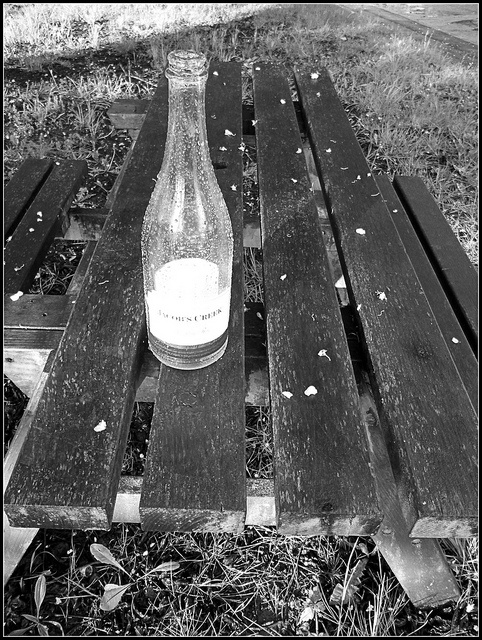Describe the objects in this image and their specific colors. I can see bench in black, gray, darkgray, and lightgray tones and bottle in black, white, darkgray, and gray tones in this image. 